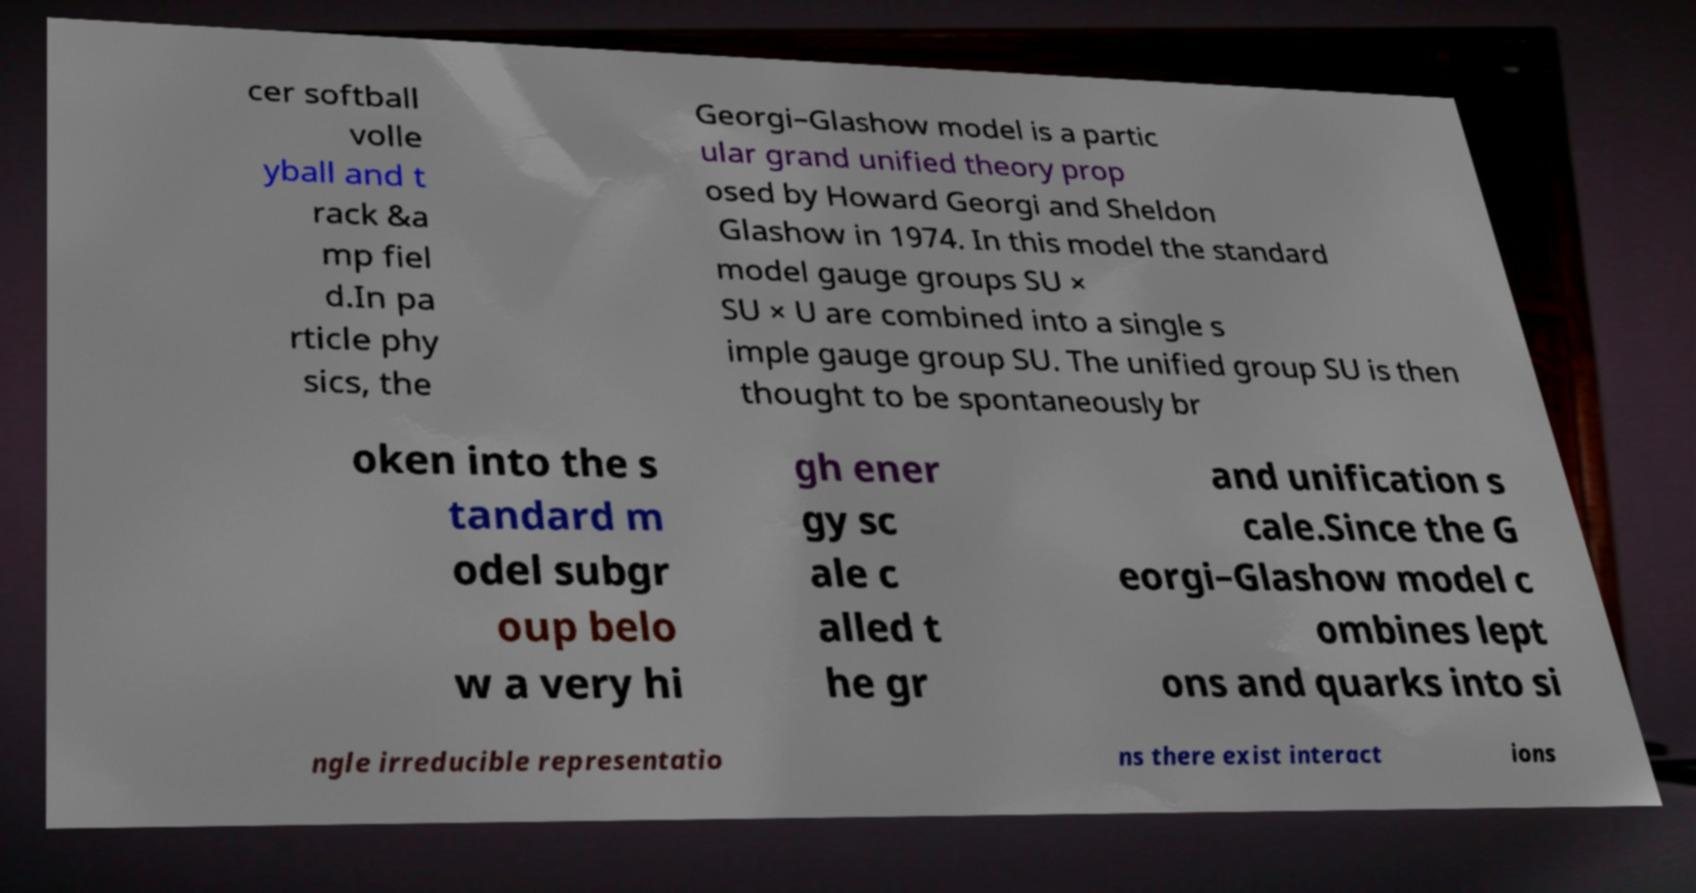Please read and relay the text visible in this image. What does it say? cer softball volle yball and t rack &a mp fiel d.In pa rticle phy sics, the Georgi–Glashow model is a partic ular grand unified theory prop osed by Howard Georgi and Sheldon Glashow in 1974. In this model the standard model gauge groups SU × SU × U are combined into a single s imple gauge group SU. The unified group SU is then thought to be spontaneously br oken into the s tandard m odel subgr oup belo w a very hi gh ener gy sc ale c alled t he gr and unification s cale.Since the G eorgi–Glashow model c ombines lept ons and quarks into si ngle irreducible representatio ns there exist interact ions 